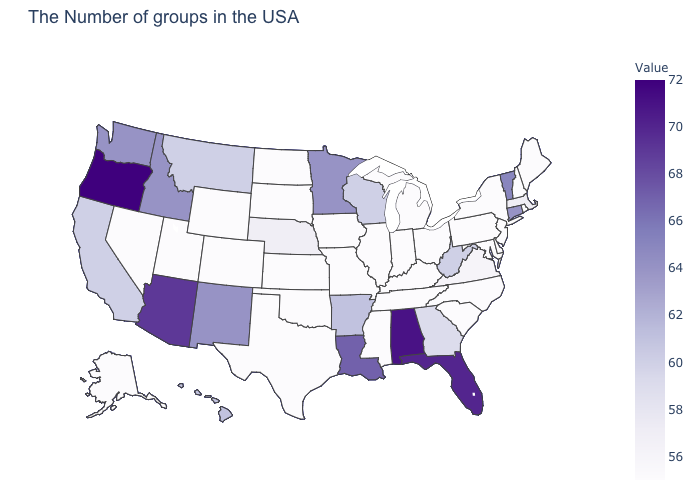Is the legend a continuous bar?
Write a very short answer. Yes. Is the legend a continuous bar?
Keep it brief. Yes. Does the map have missing data?
Be succinct. No. Does Arkansas have a higher value than New Mexico?
Give a very brief answer. No. 